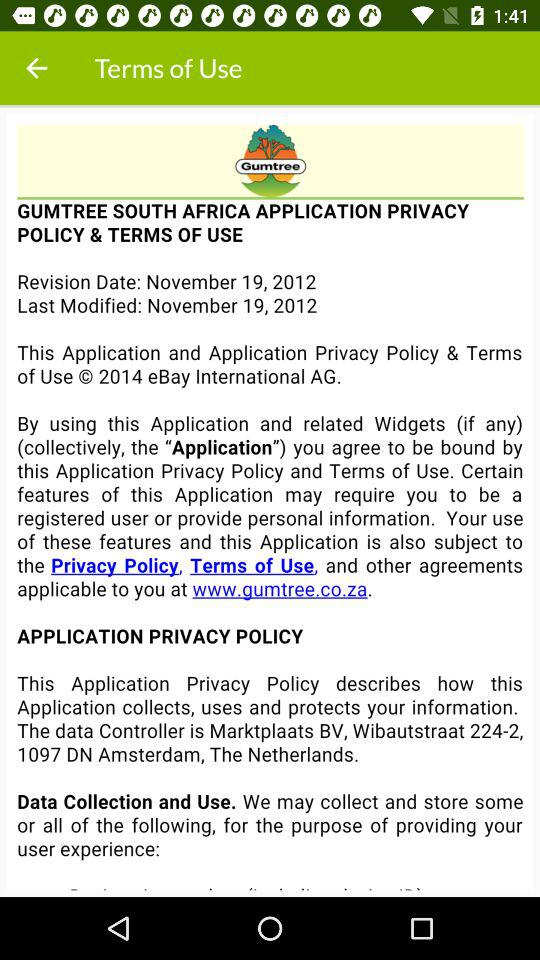On what date was the application last modified? The application was last modified on November 19, 2012. 